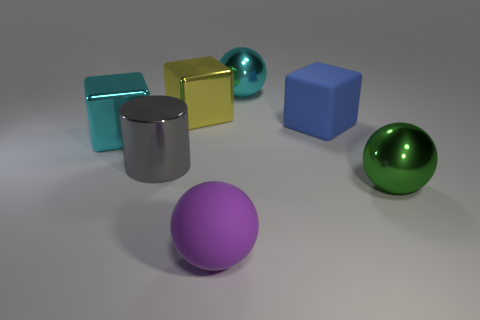There is a large cyan thing that is to the right of the big matte sphere; does it have the same shape as the cyan object that is on the left side of the big yellow block?
Ensure brevity in your answer.  No. What is the purple thing made of?
Your answer should be compact. Rubber. What number of gray things are the same size as the purple rubber sphere?
Offer a very short reply. 1. How many things are large metal objects that are behind the gray metal cylinder or cubes that are on the right side of the matte sphere?
Make the answer very short. 4. Is the material of the cyan object that is behind the big matte block the same as the big cyan thing left of the rubber ball?
Your response must be concise. Yes. There is a big cyan object that is in front of the cyan metal object to the right of the large cyan cube; what is its shape?
Give a very brief answer. Cube. Is there anything else of the same color as the big cylinder?
Make the answer very short. No. There is a cyan thing in front of the ball that is behind the big green thing; is there a large green sphere behind it?
Your answer should be compact. No. Does the large shiny sphere behind the yellow metallic cube have the same color as the big rubber object in front of the large gray cylinder?
Your answer should be compact. No. There is a cyan ball that is the same size as the shiny cylinder; what is its material?
Your response must be concise. Metal. 